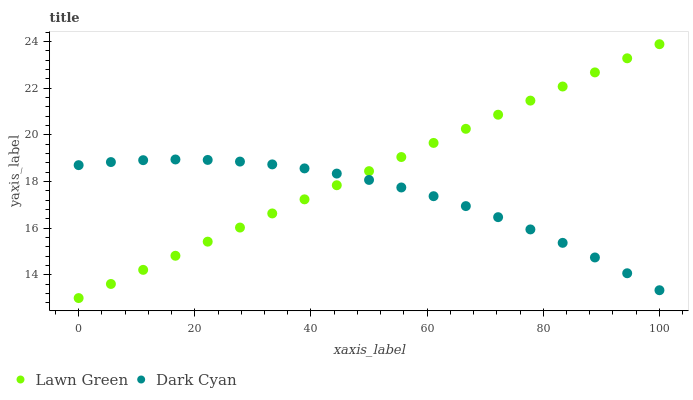Does Dark Cyan have the minimum area under the curve?
Answer yes or no. Yes. Does Lawn Green have the maximum area under the curve?
Answer yes or no. Yes. Does Lawn Green have the minimum area under the curve?
Answer yes or no. No. Is Lawn Green the smoothest?
Answer yes or no. Yes. Is Dark Cyan the roughest?
Answer yes or no. Yes. Is Lawn Green the roughest?
Answer yes or no. No. Does Lawn Green have the lowest value?
Answer yes or no. Yes. Does Lawn Green have the highest value?
Answer yes or no. Yes. Does Lawn Green intersect Dark Cyan?
Answer yes or no. Yes. Is Lawn Green less than Dark Cyan?
Answer yes or no. No. Is Lawn Green greater than Dark Cyan?
Answer yes or no. No. 